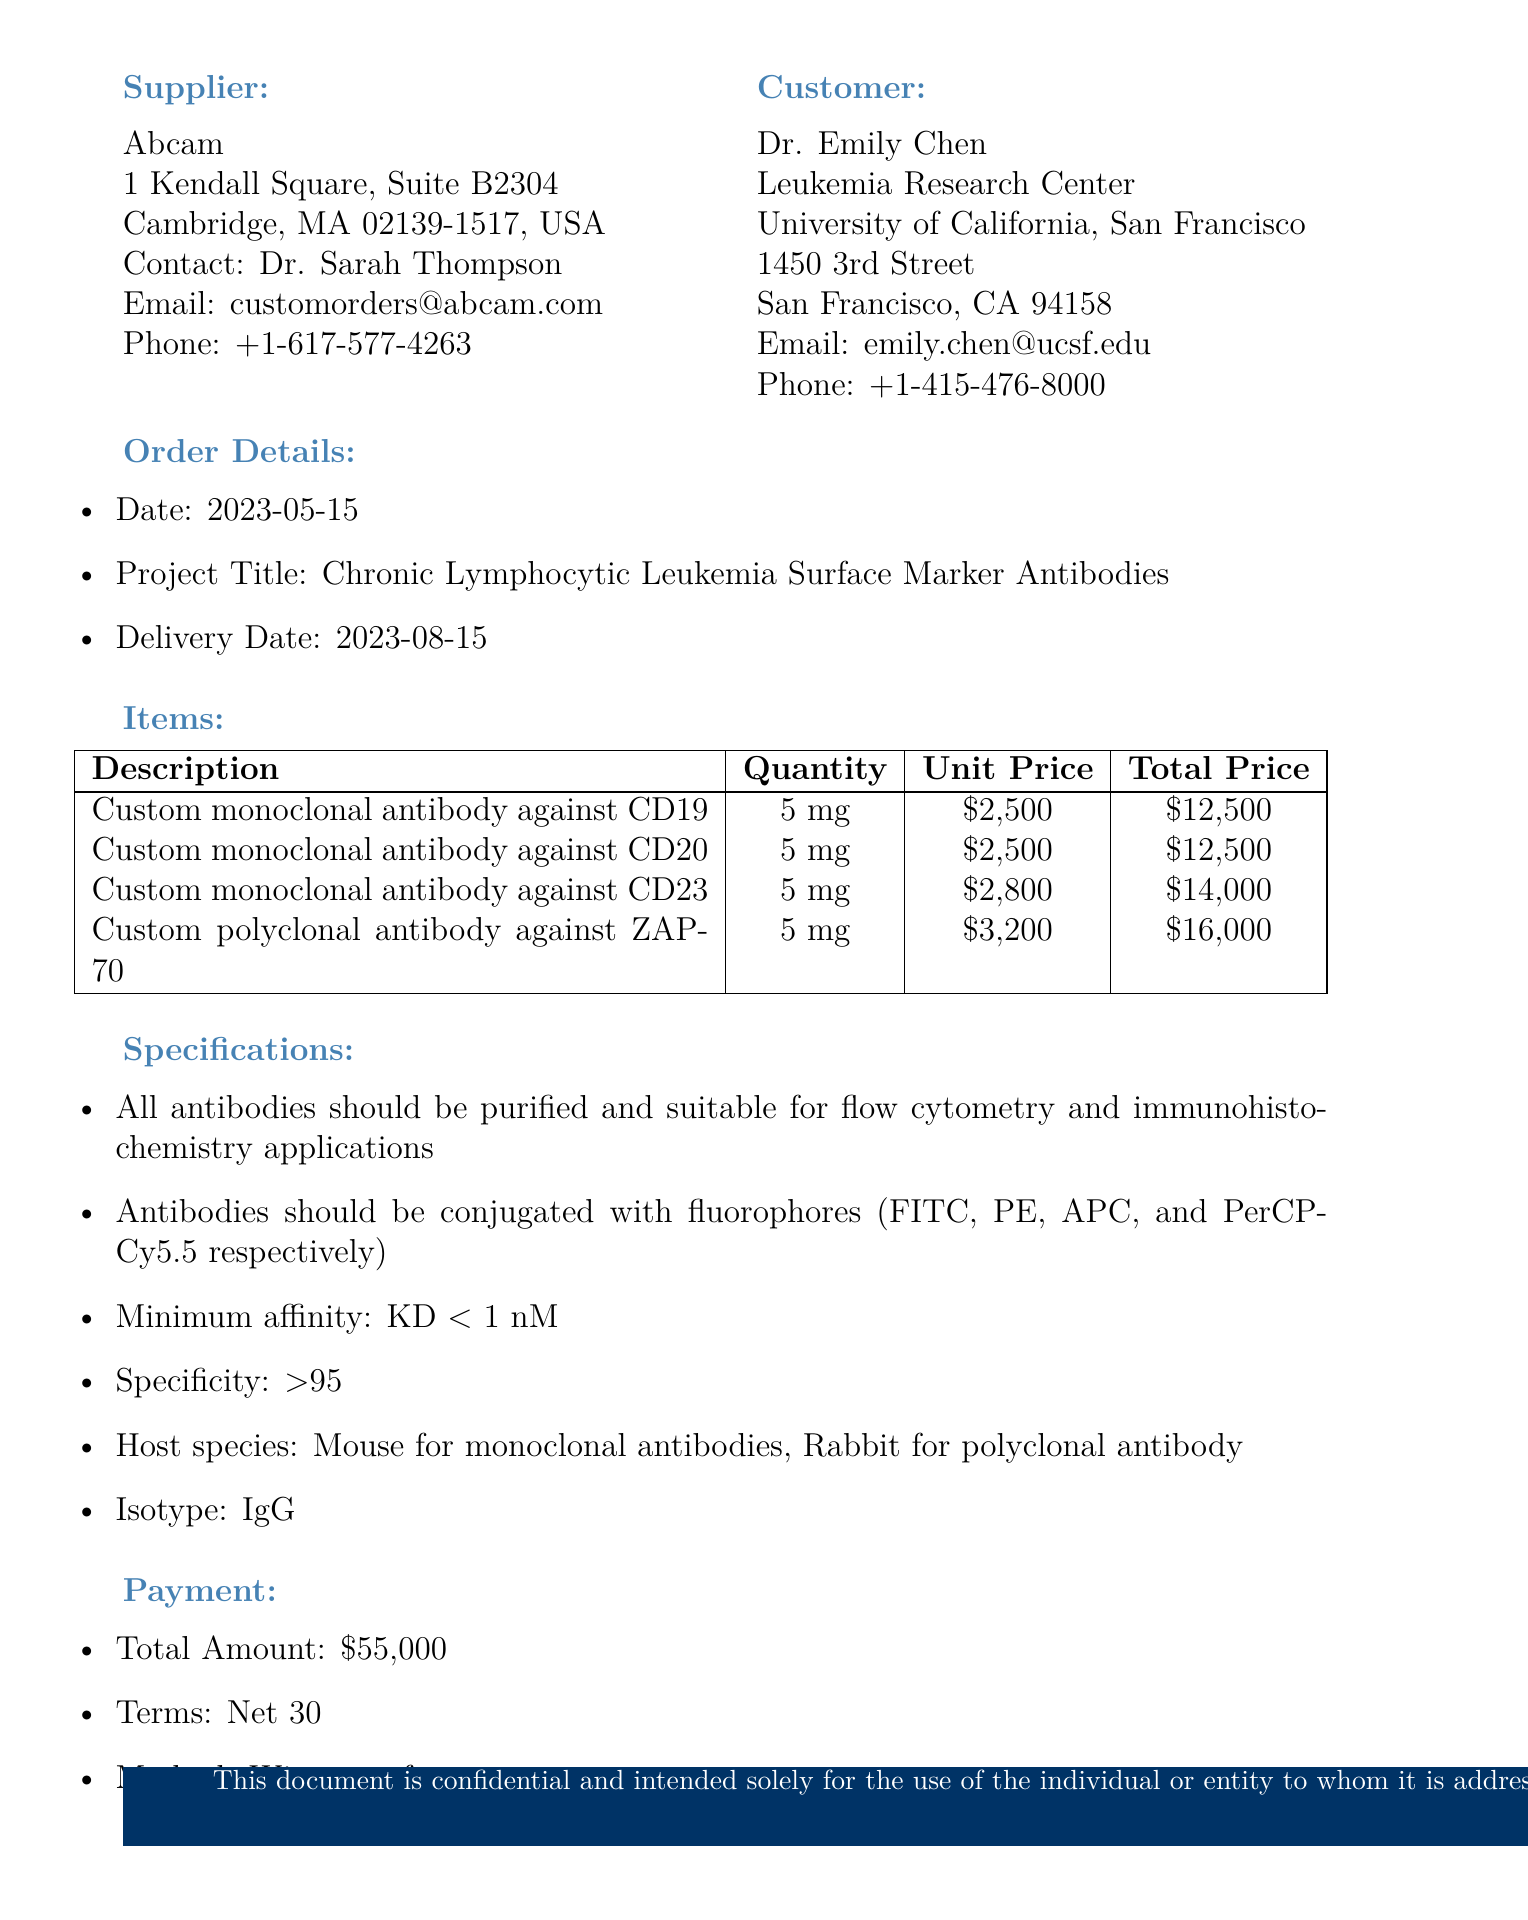What is the supplier's name? The supplier's name is mentioned prominently in the document as Abcam.
Answer: Abcam Who is the contact person at the supplier? The document lists Dr. Sarah Thompson as the contact person for the supplier.
Answer: Dr. Sarah Thompson What is the order number? The document specifies the order number as PO-CLL-2023-0542.
Answer: PO-CLL-2023-0542 What is the total amount for the order? The total amount listed in the payment section of the document totals all item costs and is provided as $55,000.
Answer: $55,000 When is the delivery date? The delivery date is provided in the order details section and is set for 2023-08-15.
Answer: 2023-08-15 What type of shipping method is used for this order? The document describes that the shipping method is overnight, temperature-controlled shipping.
Answer: Overnight, temperature-controlled shipping What are the terms of payment? The payment terms stated in the document are Net 30.
Answer: Net 30 Which antibody is against CD23? The item description provides specific details, stating that the custom monoclonal antibody against CD23 is item number 3.
Answer: Custom monoclonal antibody against CD23 What is the quantity required for the custom polyclonal antibody against ZAP-70? The quantity specified in the order details for that antibody is 5 mg.
Answer: 5 mg 